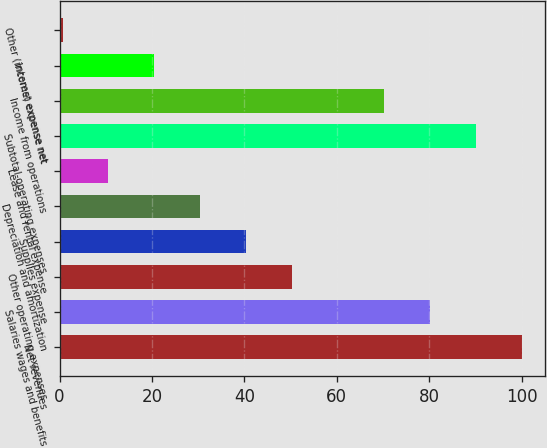<chart> <loc_0><loc_0><loc_500><loc_500><bar_chart><fcel>Net revenues<fcel>Salaries wages and benefits<fcel>Other operating expenses<fcel>Supplies expense<fcel>Depreciation and amortization<fcel>Lease and rental expense<fcel>Subtotal-operating expenses<fcel>Income from operations<fcel>Interest expense net<fcel>Other (income) expense net<nl><fcel>100.04<fcel>80.16<fcel>50.34<fcel>40.4<fcel>30.46<fcel>10.58<fcel>90.1<fcel>70.22<fcel>20.52<fcel>0.64<nl></chart> 